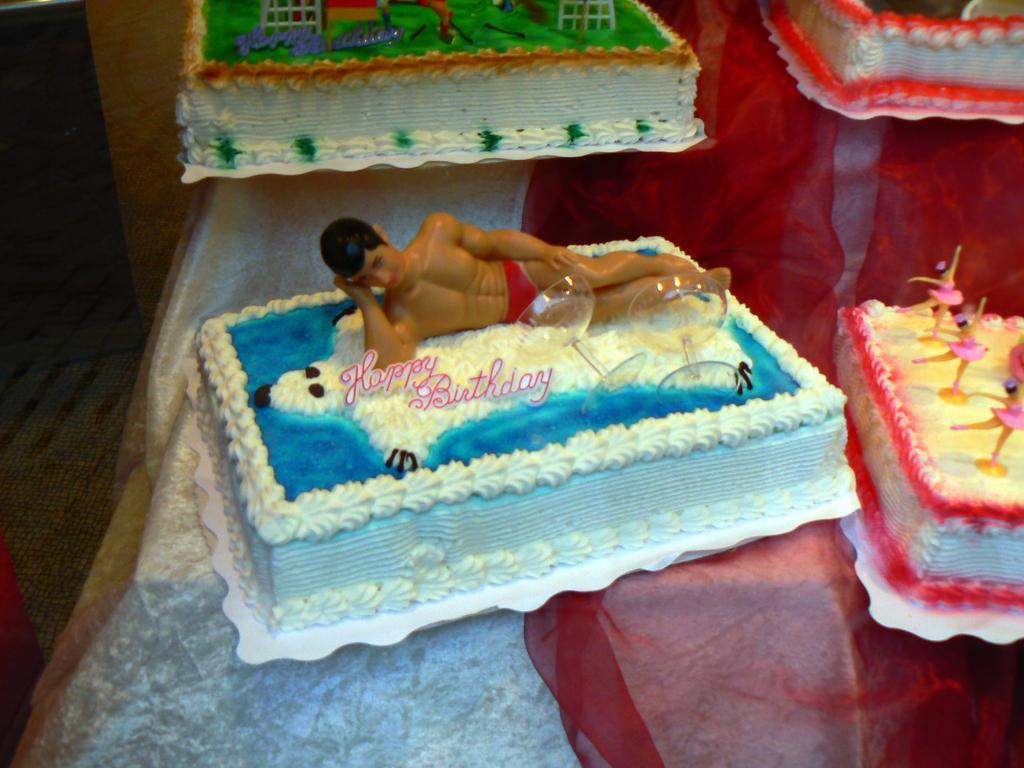Can you describe this image briefly? In this picture we can see few cakes on the table. 